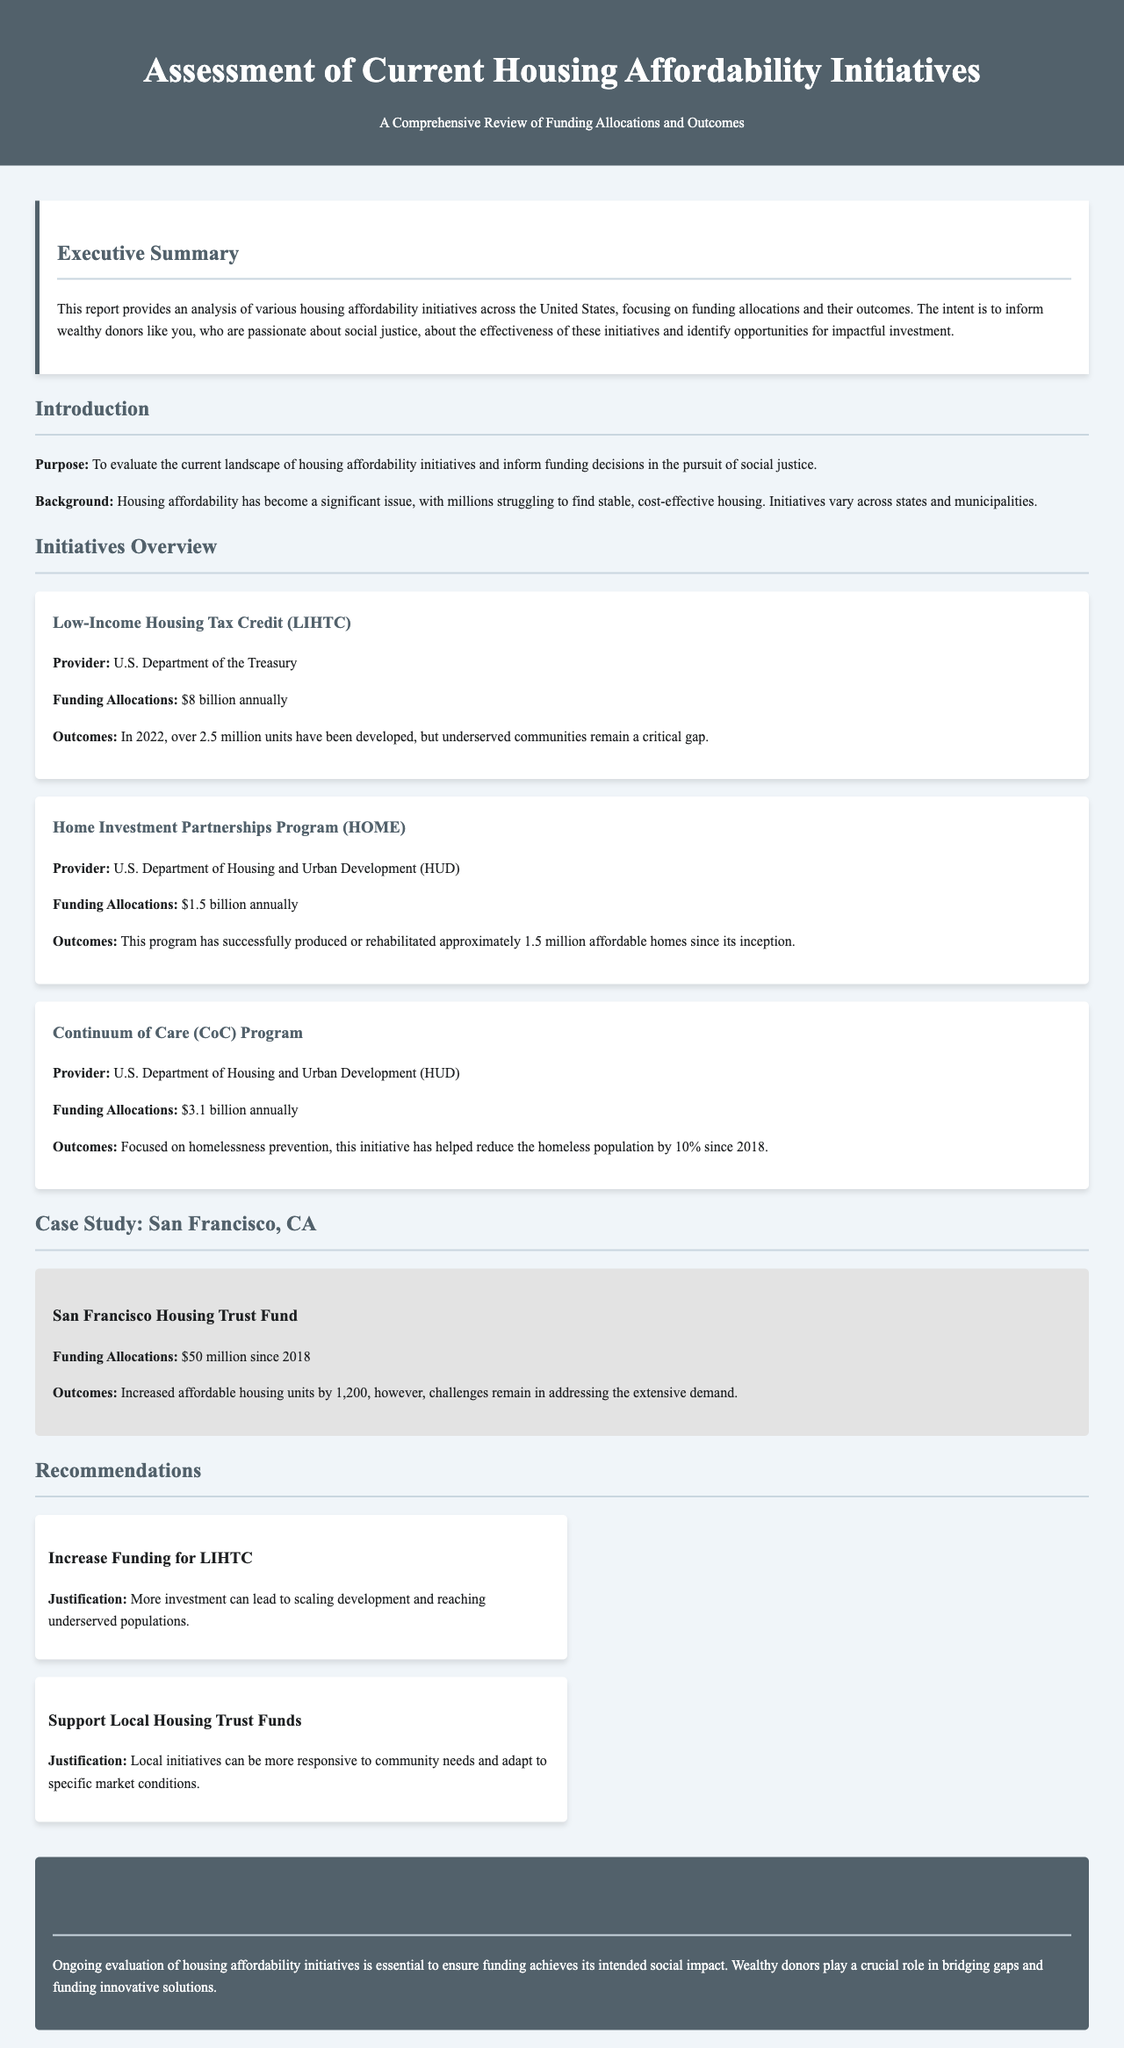What is the purpose of the report? The purpose of the report is to evaluate the current landscape of housing affordability initiatives and inform funding decisions in the pursuit of social justice.
Answer: To evaluate housing affordability initiatives What is the annual funding allocation for the Continuum of Care Program? The annual funding allocation for the Continuum of Care Program is stated in the initiatives overview section.
Answer: $3.1 billion annually How many affordable homes has the Home Investment Partnerships Program produced or rehabilitated? This information is provided in the outcomes section of the initiative overview for HOME.
Answer: Approximately 1.5 million What is the funding allocation for the San Francisco Housing Trust Fund since 2018? The report provides a specific funding allocation for this case study.
Answer: $50 million What recommendation is made regarding local housing trust funds? The recommendations section discusses the justifications for supporting local housing trust funds as a response to community needs.
Answer: Support Local Housing Trust Funds How much has the LIHTC program helped develop in terms of housing units? The outcomes for the LIHTC program provide specific numbers related to housing development.
Answer: Over 2.5 million units What percentage has the homeless population been reduced since 2018 due to the CoC Program? The outcomes section specifies the percentage reduction of homelessness attributed to the CoC Program in the document.
Answer: 10% What does the report emphasize about the role of wealthy donors? The conclusion highlights the importance of donor contributions in addressing housing gaps and funding solutions.
Answer: Crucial role in bridging gaps 